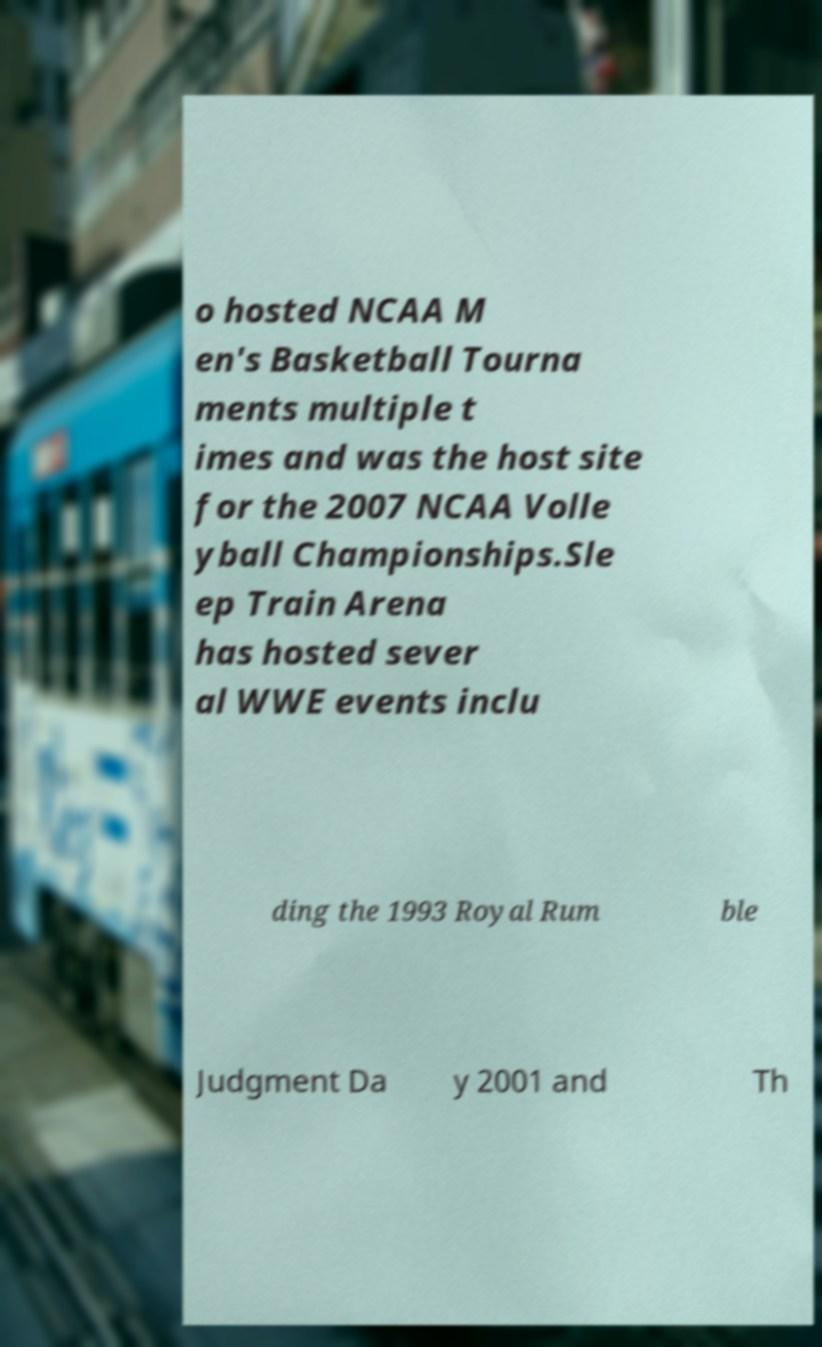I need the written content from this picture converted into text. Can you do that? o hosted NCAA M en's Basketball Tourna ments multiple t imes and was the host site for the 2007 NCAA Volle yball Championships.Sle ep Train Arena has hosted sever al WWE events inclu ding the 1993 Royal Rum ble Judgment Da y 2001 and Th 